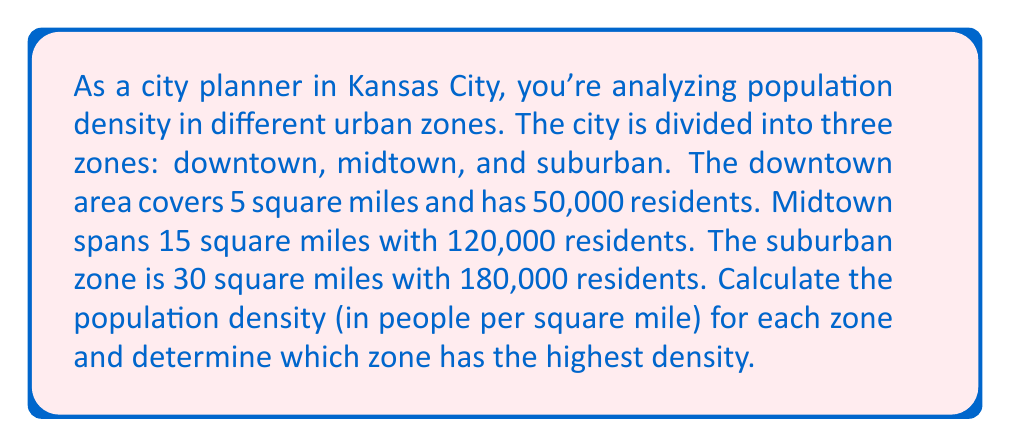Could you help me with this problem? To solve this problem, we need to calculate the population density for each zone and then compare them. Population density is calculated by dividing the population by the area.

1. Downtown:
   Area = 5 square miles
   Population = 50,000
   Density = $\frac{Population}{Area} = \frac{50,000}{5} = 10,000$ people per square mile

2. Midtown:
   Area = 15 square miles
   Population = 120,000
   Density = $\frac{Population}{Area} = \frac{120,000}{15} = 8,000$ people per square mile

3. Suburban:
   Area = 30 square miles
   Population = 180,000
   Density = $\frac{Population}{Area} = \frac{180,000}{30} = 6,000$ people per square mile

Now, let's compare the densities:
Downtown: 10,000 people/sq mile
Midtown: 8,000 people/sq mile
Suburban: 6,000 people/sq mile

The downtown area has the highest population density.
Answer: Downtown: 10,000 people/sq mile
Midtown: 8,000 people/sq mile
Suburban: 6,000 people/sq mile

The downtown zone has the highest population density at 10,000 people per square mile. 